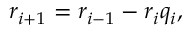<formula> <loc_0><loc_0><loc_500><loc_500>r _ { i + 1 } = r _ { i - 1 } - r _ { i } q _ { i } ,</formula> 